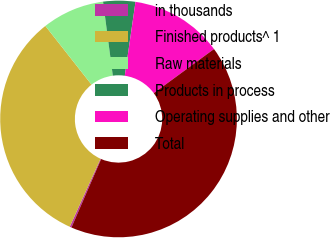Convert chart to OTSL. <chart><loc_0><loc_0><loc_500><loc_500><pie_chart><fcel>in thousands<fcel>Finished products^ 1<fcel>Raw materials<fcel>Products in process<fcel>Operating supplies and other<fcel>Total<nl><fcel>0.25%<fcel>32.63%<fcel>8.52%<fcel>4.38%<fcel>12.65%<fcel>41.58%<nl></chart> 